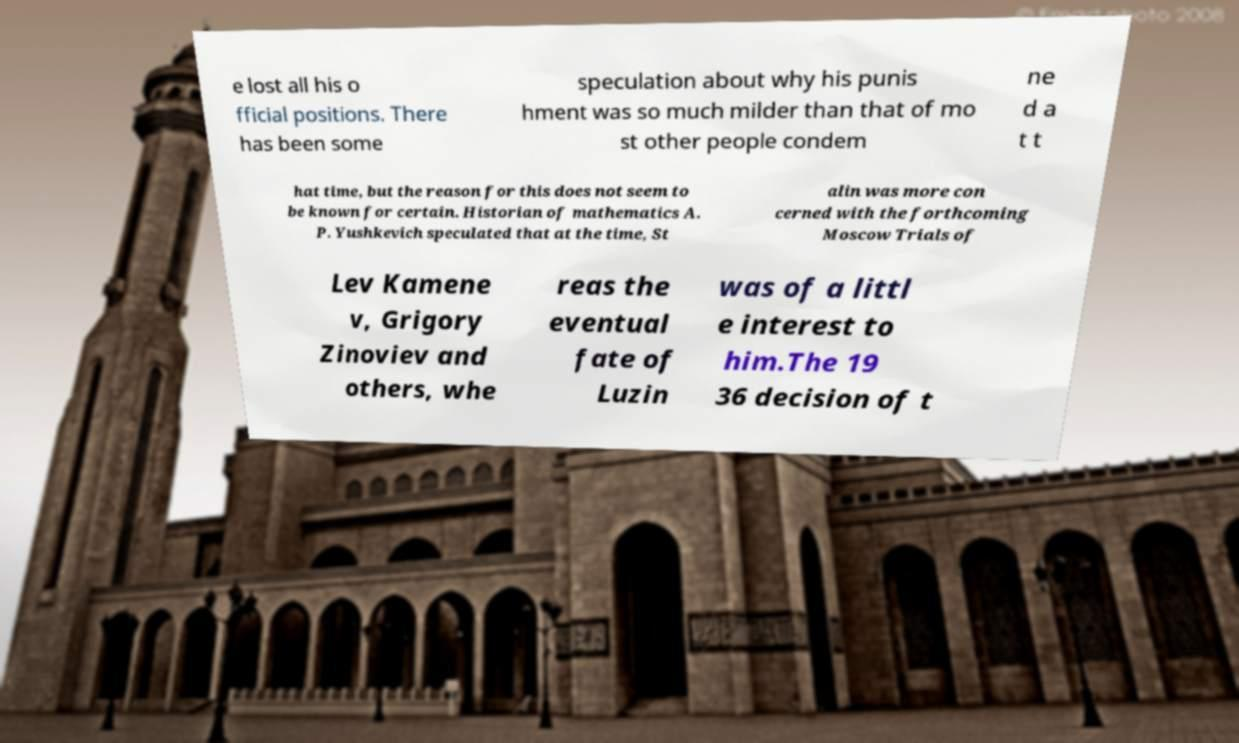Could you assist in decoding the text presented in this image and type it out clearly? e lost all his o fficial positions. There has been some speculation about why his punis hment was so much milder than that of mo st other people condem ne d a t t hat time, but the reason for this does not seem to be known for certain. Historian of mathematics A. P. Yushkevich speculated that at the time, St alin was more con cerned with the forthcoming Moscow Trials of Lev Kamene v, Grigory Zinoviev and others, whe reas the eventual fate of Luzin was of a littl e interest to him.The 19 36 decision of t 